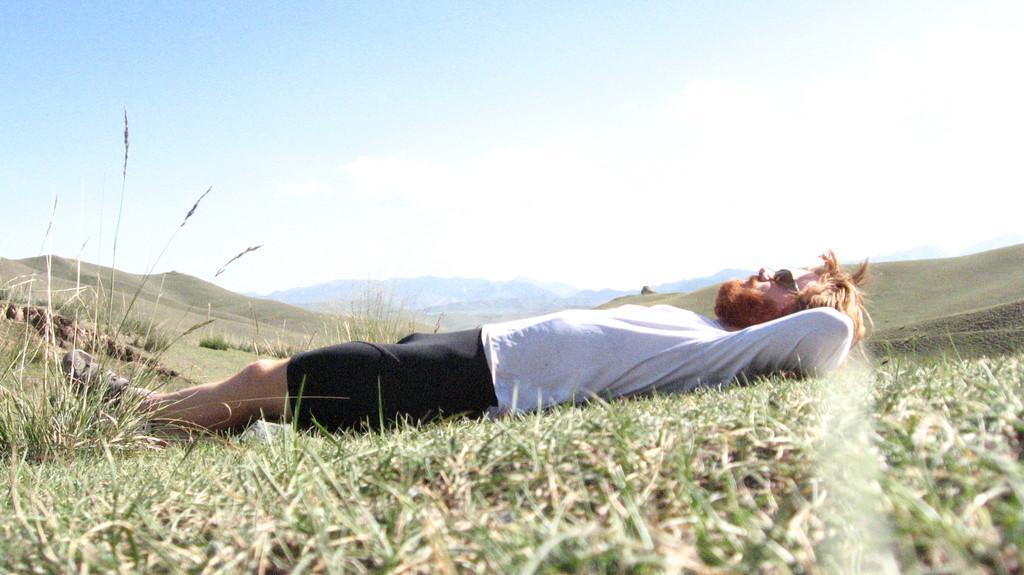Could you give a brief overview of what you see in this image? In this picture we can see a man is lying on the grass. Behind the man there are hills and the sky. 